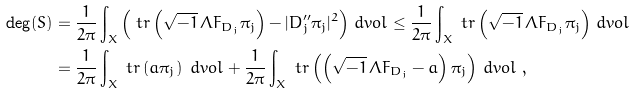<formula> <loc_0><loc_0><loc_500><loc_500>\deg ( S ) & = \frac { 1 } { 2 \pi } \int _ { X } \left ( \ t r \left ( \sqrt { - 1 } \, \Lambda F _ { D _ { j } } \pi _ { j } \right ) - | D _ { j } ^ { \prime \prime } \pi _ { j } | ^ { 2 } \right ) \, d v o l \leq \frac { 1 } { 2 \pi } \int _ { X } \ t r \left ( \sqrt { - 1 } \, \Lambda F _ { D _ { j } } \pi _ { j } \right ) \, d v o l \\ & = \frac { 1 } { 2 \pi } \int _ { X } \ t r \left ( { a } \pi _ { j } \right ) \ d v o l + \frac { 1 } { 2 \pi } \int _ { X } \ t r \left ( \left ( \sqrt { - 1 } \, \Lambda F _ { D _ { j } } - { a } \right ) \pi _ { j } \right ) \, d v o l \ ,</formula> 